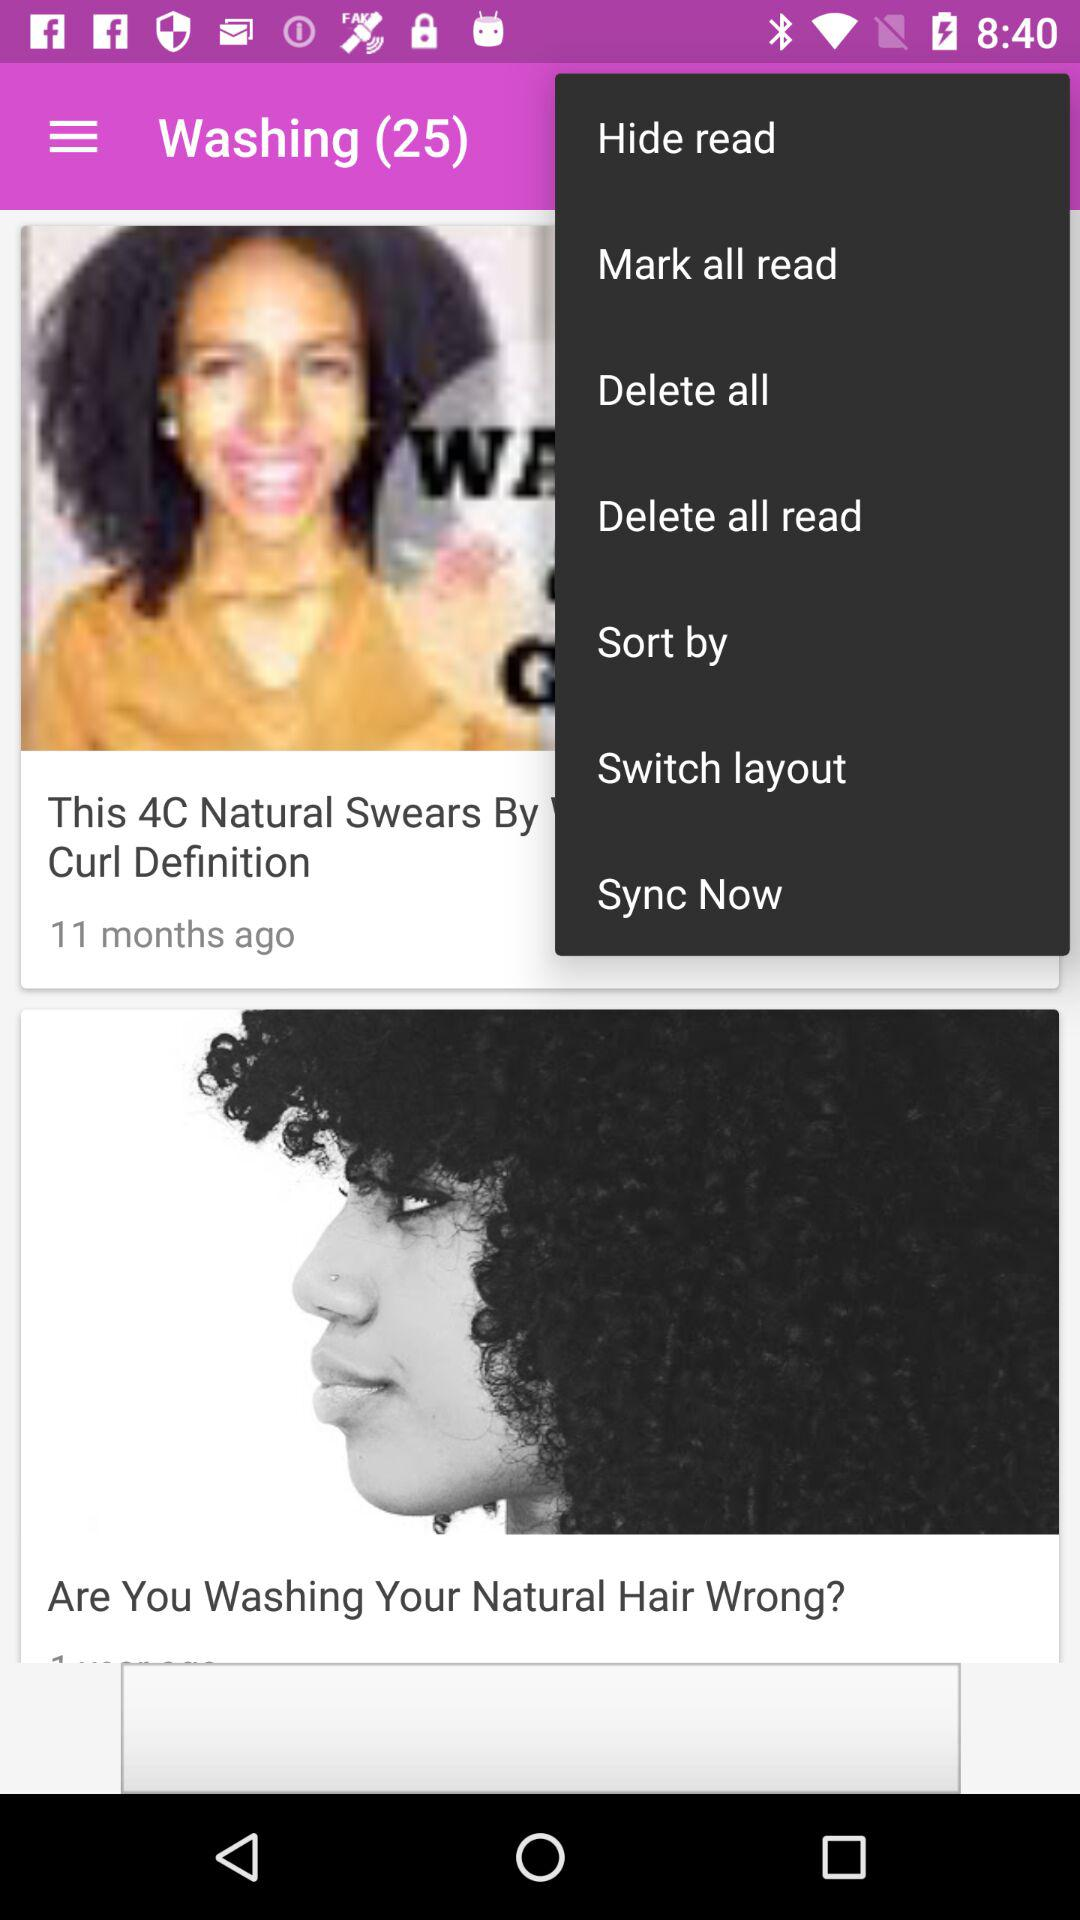How many results are shown for "Washing"? There are 25 results shown for "Washing". 